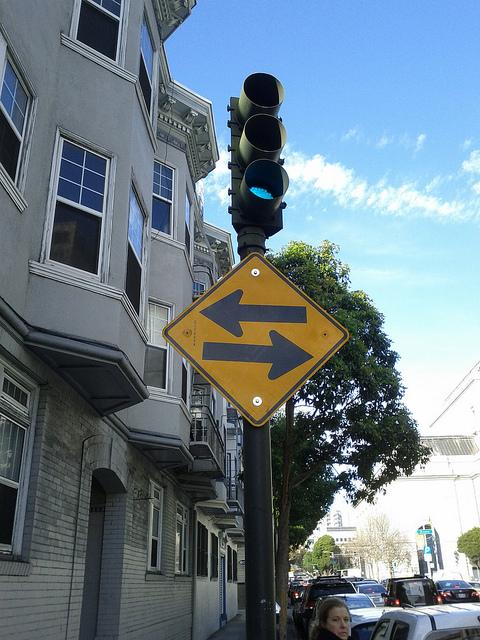Where does the woman stand at? Please explain your reasoning. intersection. There is a sign that has arrows pointing other ways. 